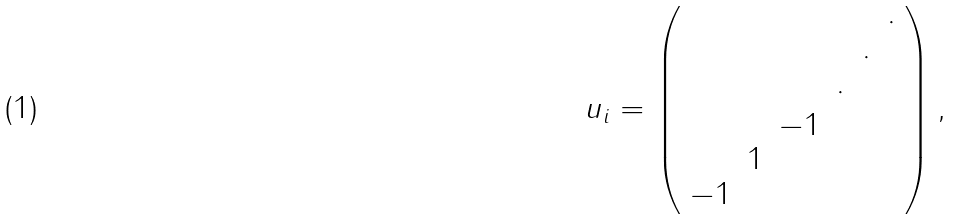<formula> <loc_0><loc_0><loc_500><loc_500>u _ { i } = \left ( \begin{array} { c c c c c c } & & & & & \cdot \\ & & & & \cdot & \\ & & & \cdot & & \\ & & - 1 & & & \\ & 1 & & & & \\ - 1 & & & & & \\ \end{array} \right ) ,</formula> 